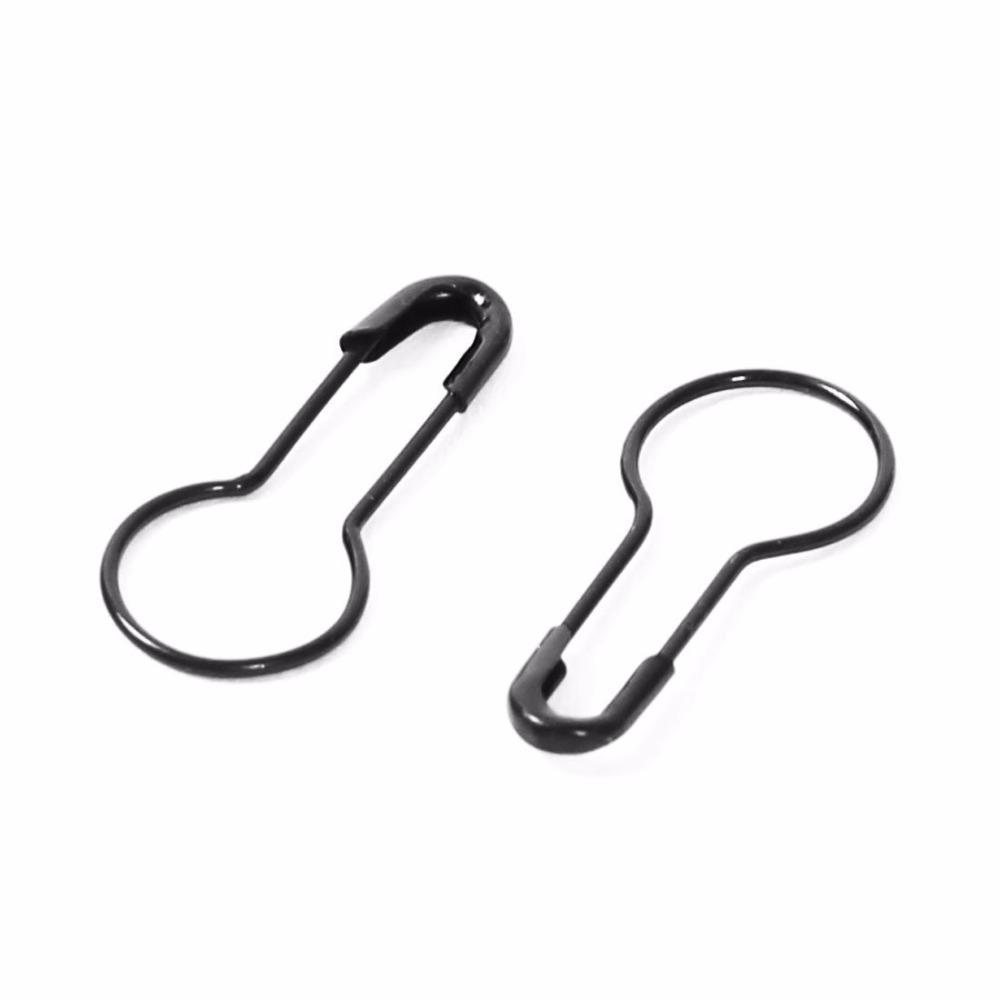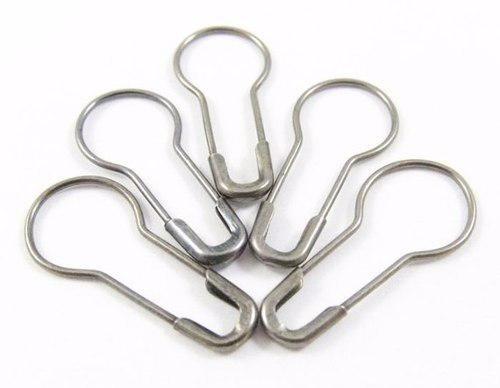The first image is the image on the left, the second image is the image on the right. Analyze the images presented: Is the assertion "There are more pins in the image on the right than in the image on the left." valid? Answer yes or no. Yes. 